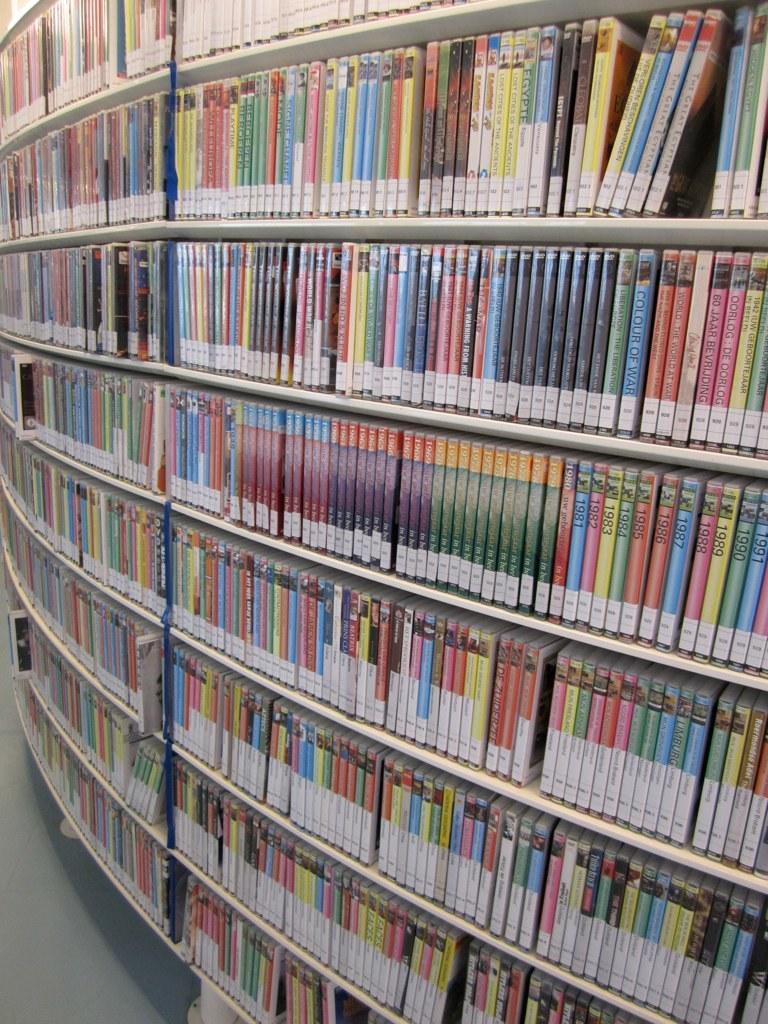In one or two sentences, can you explain what this image depicts? In this image there are books placed on a bookshelf. 